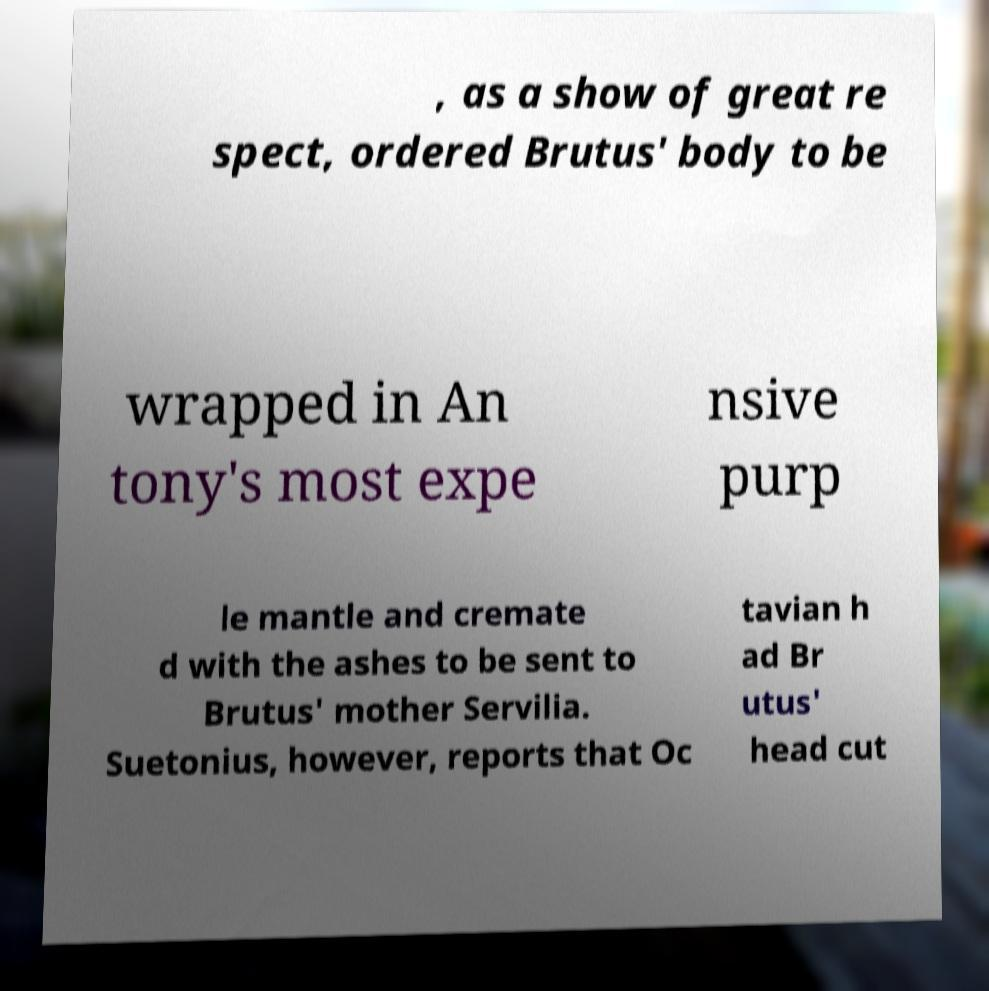Please read and relay the text visible in this image. What does it say? , as a show of great re spect, ordered Brutus' body to be wrapped in An tony's most expe nsive purp le mantle and cremate d with the ashes to be sent to Brutus' mother Servilia. Suetonius, however, reports that Oc tavian h ad Br utus' head cut 